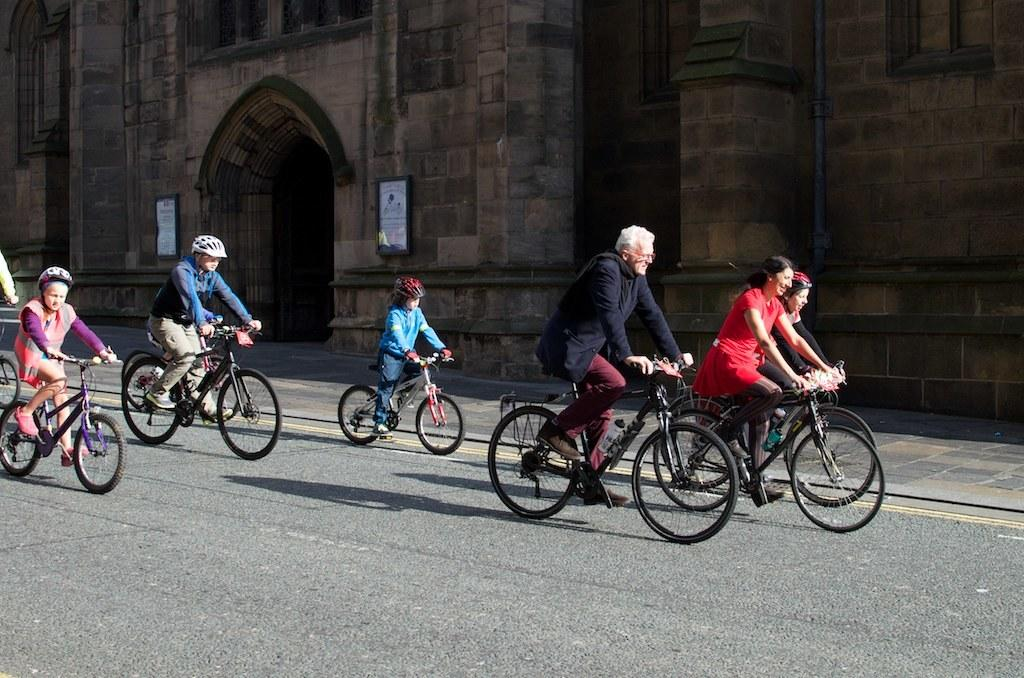What are the people in the image doing? The people in the image are cycling. What type of vehicles are the people riding? The people are riding bicycles. What can be seen in the image besides the people cycling? There is a road visible in the image. What is visible in the background of the image? There is a building in the background of the image. How many holes can be seen in the bicycle tires in the image? There is no information about the number of holes in the bicycle tires in the image, nor are any holes visible. 